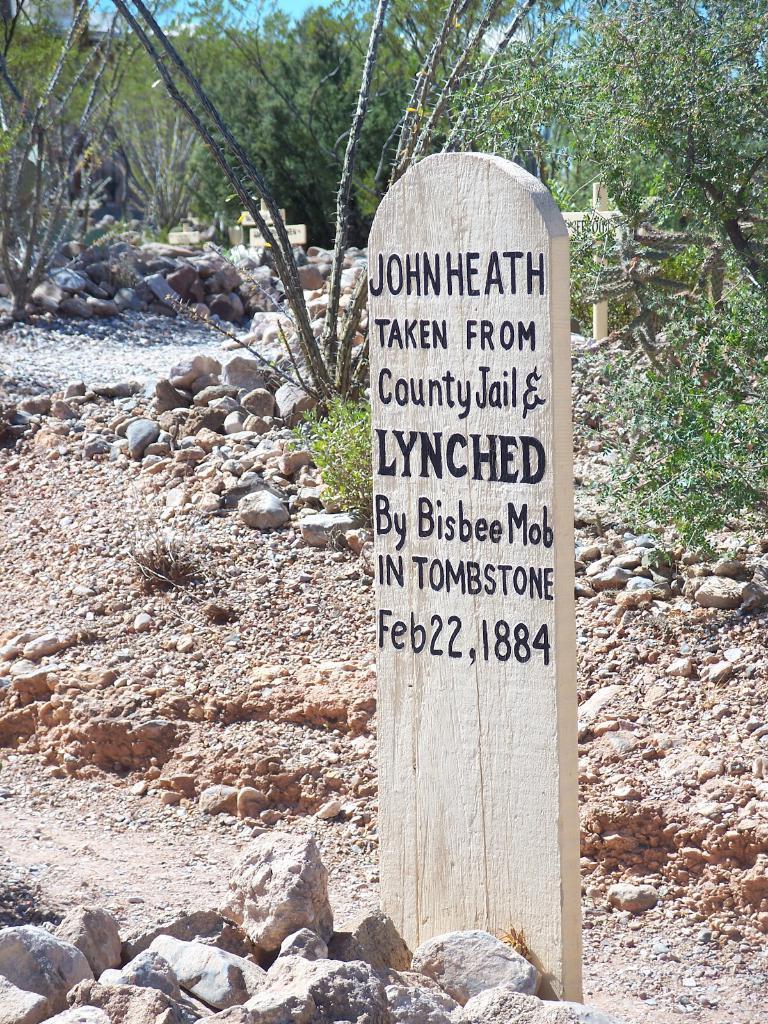How would you summarize this image in a sentence or two? In this image I can see a cemetery. Background I can see few rocks, trees in green color and sky in blue color. 